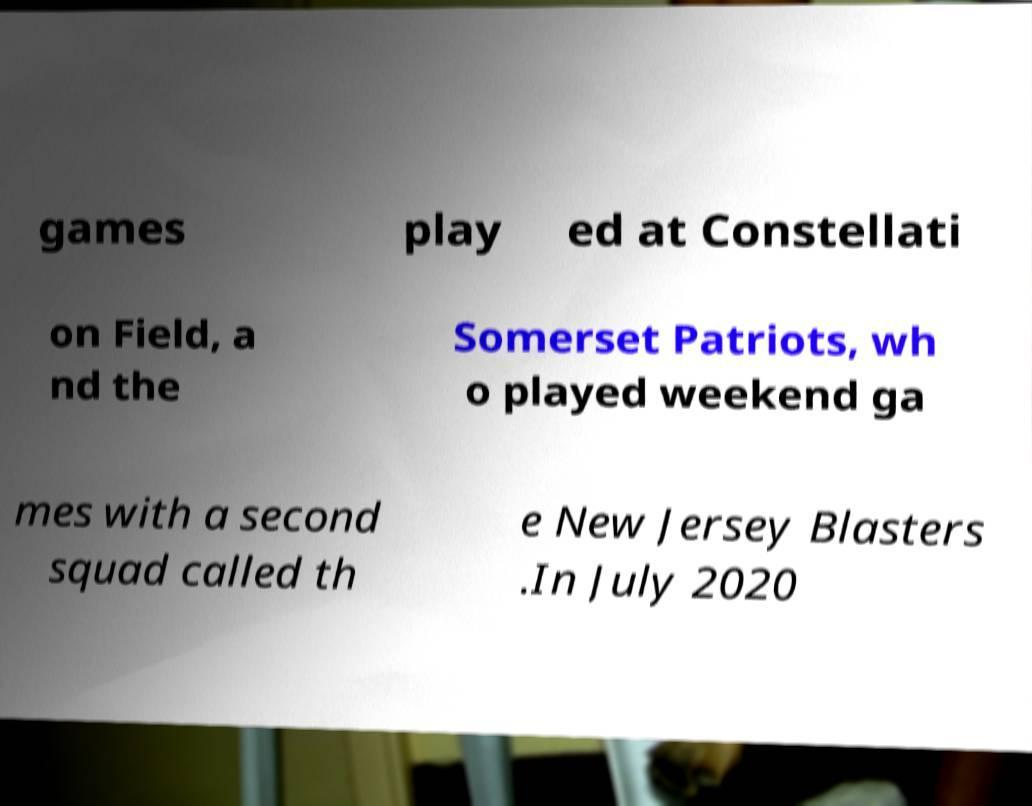What messages or text are displayed in this image? I need them in a readable, typed format. games play ed at Constellati on Field, a nd the Somerset Patriots, wh o played weekend ga mes with a second squad called th e New Jersey Blasters .In July 2020 